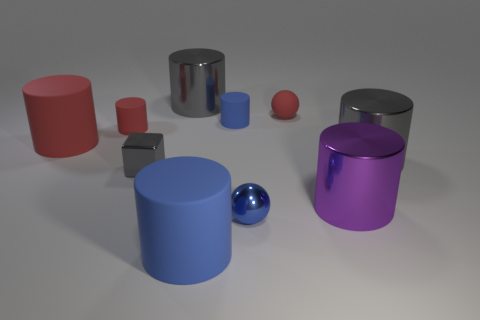There is a big red thing that is the same shape as the large blue matte thing; what is its material?
Your answer should be very brief. Rubber. How many things are either cylinders in front of the tiny blue matte object or metal things that are right of the blue ball?
Offer a terse response. 5. How many other objects are the same color as the shiny cube?
Give a very brief answer. 2. Is the number of gray things that are on the right side of the large blue matte thing greater than the number of spheres to the left of the small gray metal thing?
Your response must be concise. Yes. What number of balls are either tiny gray shiny objects or large gray objects?
Offer a terse response. 0. What number of objects are gray cylinders on the right side of the big blue object or red matte cylinders?
Make the answer very short. 3. What shape is the big gray metallic object behind the big gray metal cylinder in front of the large matte thing that is left of the large blue rubber cylinder?
Give a very brief answer. Cylinder. What number of gray objects are the same shape as the purple metallic thing?
Offer a very short reply. 2. There is a large thing that is the same color as the tiny rubber sphere; what is it made of?
Your response must be concise. Rubber. Is the material of the block the same as the big blue cylinder?
Make the answer very short. No. 